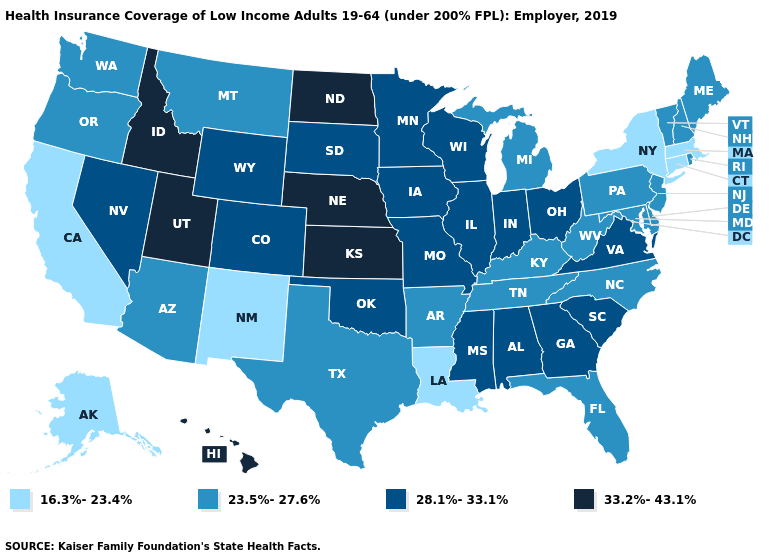What is the value of Nebraska?
Be succinct. 33.2%-43.1%. What is the value of Michigan?
Write a very short answer. 23.5%-27.6%. Name the states that have a value in the range 23.5%-27.6%?
Quick response, please. Arizona, Arkansas, Delaware, Florida, Kentucky, Maine, Maryland, Michigan, Montana, New Hampshire, New Jersey, North Carolina, Oregon, Pennsylvania, Rhode Island, Tennessee, Texas, Vermont, Washington, West Virginia. Which states have the lowest value in the USA?
Keep it brief. Alaska, California, Connecticut, Louisiana, Massachusetts, New Mexico, New York. Name the states that have a value in the range 16.3%-23.4%?
Give a very brief answer. Alaska, California, Connecticut, Louisiana, Massachusetts, New Mexico, New York. What is the value of Ohio?
Be succinct. 28.1%-33.1%. Does South Carolina have the same value as Vermont?
Quick response, please. No. What is the highest value in the USA?
Give a very brief answer. 33.2%-43.1%. What is the value of Alaska?
Short answer required. 16.3%-23.4%. Name the states that have a value in the range 28.1%-33.1%?
Give a very brief answer. Alabama, Colorado, Georgia, Illinois, Indiana, Iowa, Minnesota, Mississippi, Missouri, Nevada, Ohio, Oklahoma, South Carolina, South Dakota, Virginia, Wisconsin, Wyoming. Which states have the lowest value in the South?
Keep it brief. Louisiana. What is the value of Wyoming?
Short answer required. 28.1%-33.1%. Does New York have the lowest value in the Northeast?
Write a very short answer. Yes. What is the highest value in the West ?
Be succinct. 33.2%-43.1%. Which states hav the highest value in the MidWest?
Short answer required. Kansas, Nebraska, North Dakota. 